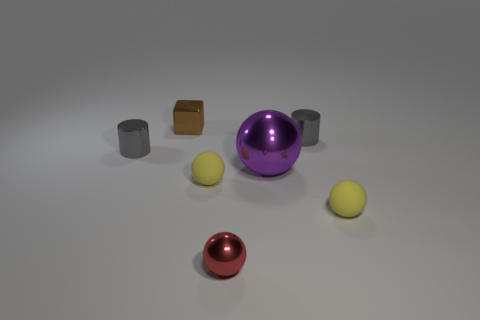Subtract all cyan spheres. Subtract all red blocks. How many spheres are left? 4 Add 3 yellow balls. How many objects exist? 10 Subtract all cylinders. How many objects are left? 5 Add 7 yellow rubber objects. How many yellow rubber objects exist? 9 Subtract 1 purple balls. How many objects are left? 6 Subtract all metal objects. Subtract all big cyan matte cubes. How many objects are left? 2 Add 6 small gray cylinders. How many small gray cylinders are left? 8 